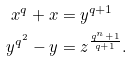<formula> <loc_0><loc_0><loc_500><loc_500>x ^ { q } + x & = y ^ { q + 1 } \\ y ^ { q ^ { 2 } } - y & = z ^ { \frac { q ^ { n } + 1 } { q + 1 } } .</formula> 